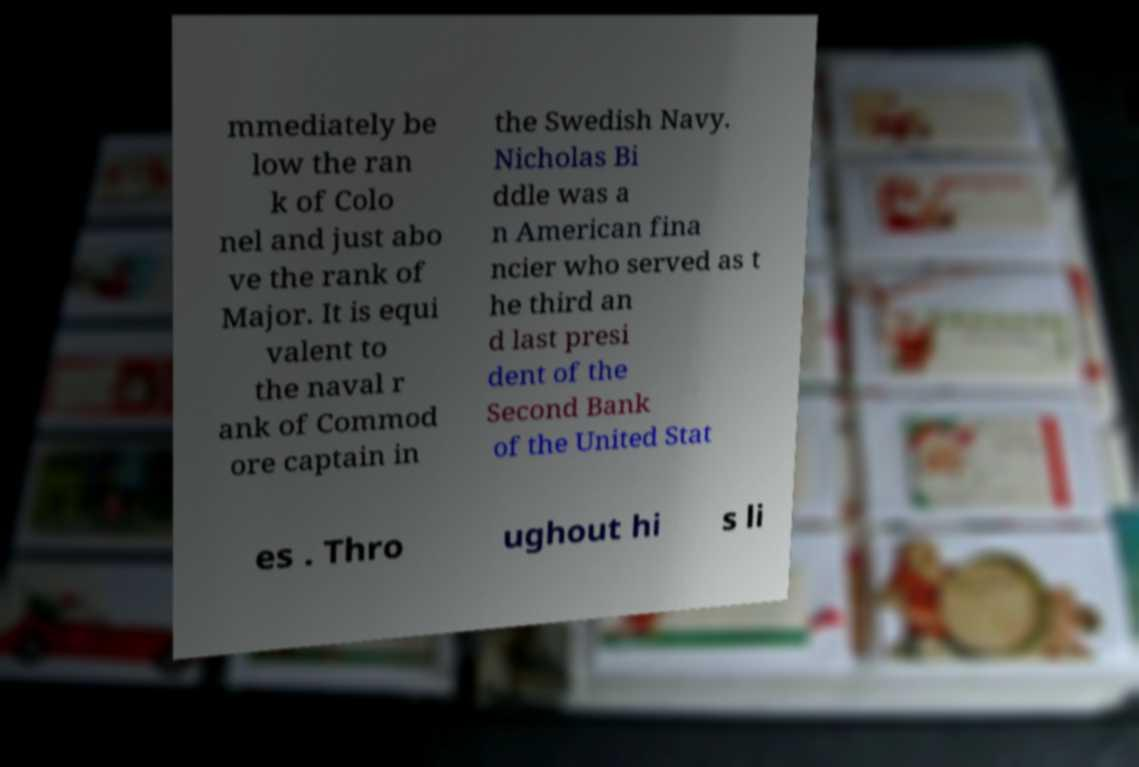For documentation purposes, I need the text within this image transcribed. Could you provide that? mmediately be low the ran k of Colo nel and just abo ve the rank of Major. It is equi valent to the naval r ank of Commod ore captain in the Swedish Navy. Nicholas Bi ddle was a n American fina ncier who served as t he third an d last presi dent of the Second Bank of the United Stat es . Thro ughout hi s li 